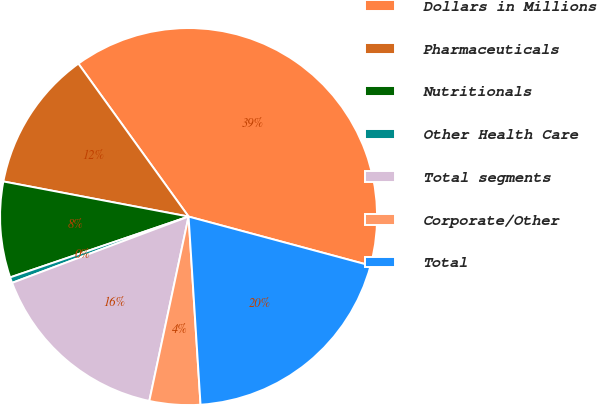Convert chart. <chart><loc_0><loc_0><loc_500><loc_500><pie_chart><fcel>Dollars in Millions<fcel>Pharmaceuticals<fcel>Nutritionals<fcel>Other Health Care<fcel>Total segments<fcel>Corporate/Other<fcel>Total<nl><fcel>39.12%<fcel>12.08%<fcel>8.21%<fcel>0.49%<fcel>15.94%<fcel>4.35%<fcel>19.8%<nl></chart> 